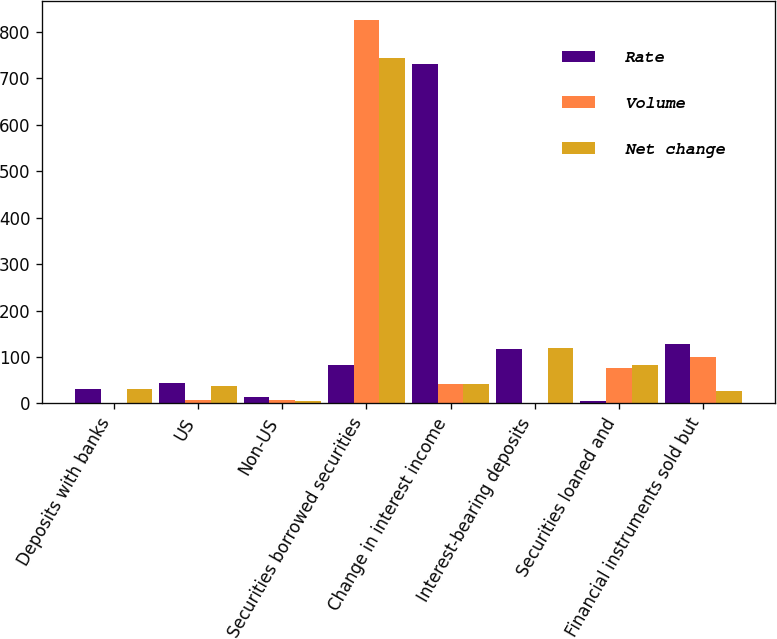Convert chart. <chart><loc_0><loc_0><loc_500><loc_500><stacked_bar_chart><ecel><fcel>Deposits with banks<fcel>US<fcel>Non-US<fcel>Securities borrowed securities<fcel>Change in interest income<fcel>Interest-bearing deposits<fcel>Securities loaned and<fcel>Financial instruments sold but<nl><fcel>Rate<fcel>32<fcel>45<fcel>13<fcel>83<fcel>730<fcel>118<fcel>6<fcel>127<nl><fcel>Volume<fcel>1<fcel>8<fcel>7<fcel>826<fcel>41<fcel>1<fcel>77<fcel>101<nl><fcel>Net change<fcel>31<fcel>37<fcel>6<fcel>743<fcel>41<fcel>119<fcel>83<fcel>26<nl></chart> 